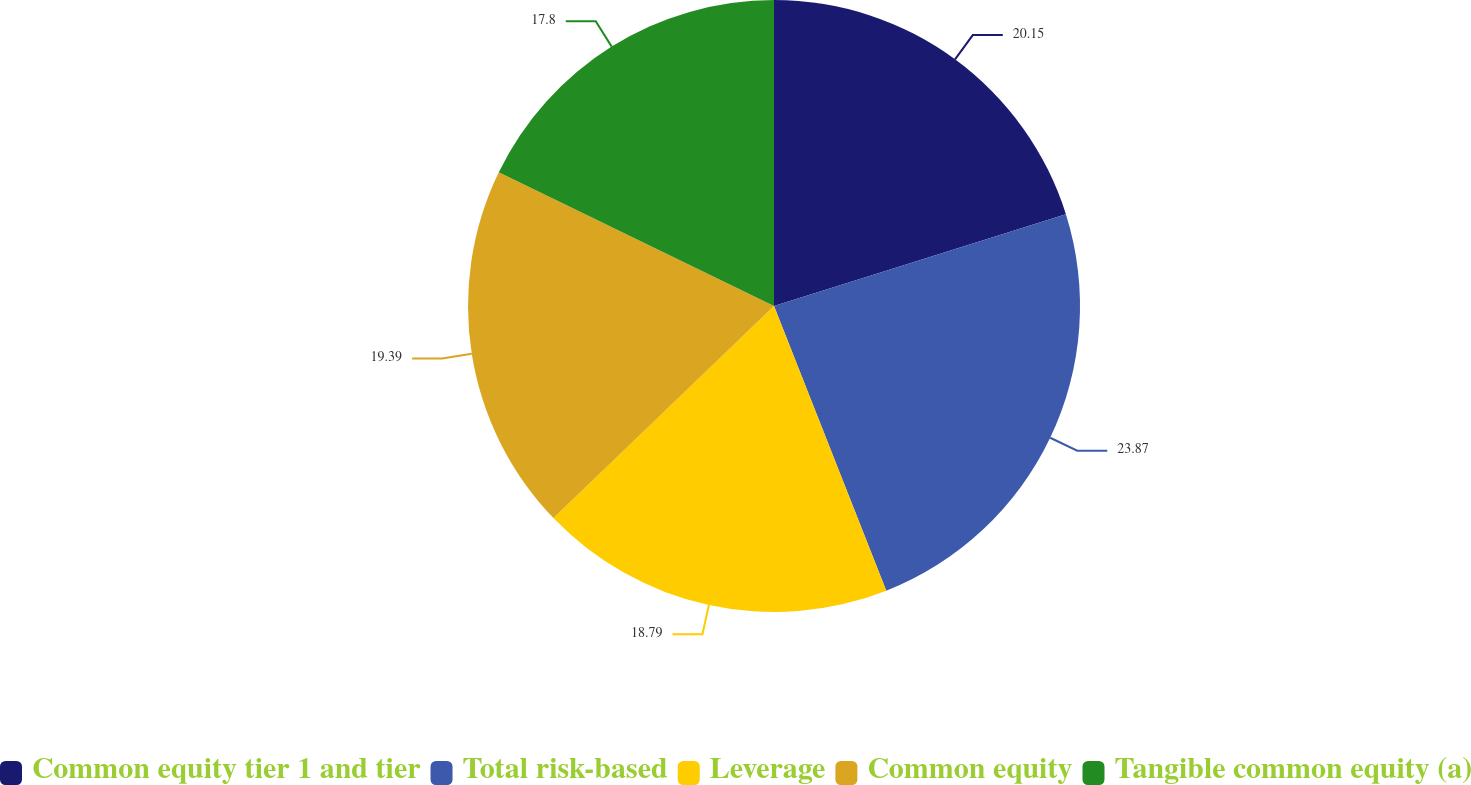<chart> <loc_0><loc_0><loc_500><loc_500><pie_chart><fcel>Common equity tier 1 and tier<fcel>Total risk-based<fcel>Leverage<fcel>Common equity<fcel>Tangible common equity (a)<nl><fcel>20.15%<fcel>23.87%<fcel>18.79%<fcel>19.39%<fcel>17.8%<nl></chart> 